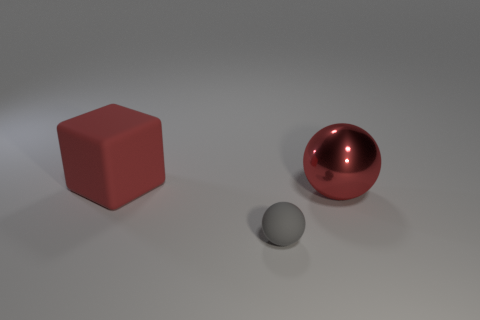There is a object that is left of the large ball and behind the small matte ball; what is its shape?
Your response must be concise. Cube. There is a block that is made of the same material as the small gray object; what color is it?
Your answer should be compact. Red. Is the number of gray things to the left of the big red rubber thing the same as the number of tiny blue rubber balls?
Offer a terse response. Yes. The red rubber thing that is the same size as the red ball is what shape?
Offer a terse response. Cube. What number of other things are the same shape as the tiny gray object?
Your answer should be compact. 1. There is a red metal sphere; does it have the same size as the matte thing on the left side of the rubber sphere?
Your answer should be compact. Yes. What number of objects are red objects right of the gray rubber ball or tiny green cylinders?
Your answer should be very brief. 1. What is the shape of the large object that is in front of the large red matte object?
Ensure brevity in your answer.  Sphere. Are there an equal number of small gray balls behind the big red block and big metal balls that are in front of the tiny thing?
Your response must be concise. Yes. The object that is both to the left of the big shiny ball and behind the gray rubber sphere is what color?
Provide a succinct answer. Red. 